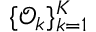Convert formula to latex. <formula><loc_0><loc_0><loc_500><loc_500>\{ \mathcal { O } _ { k } \} _ { k = 1 } ^ { K }</formula> 